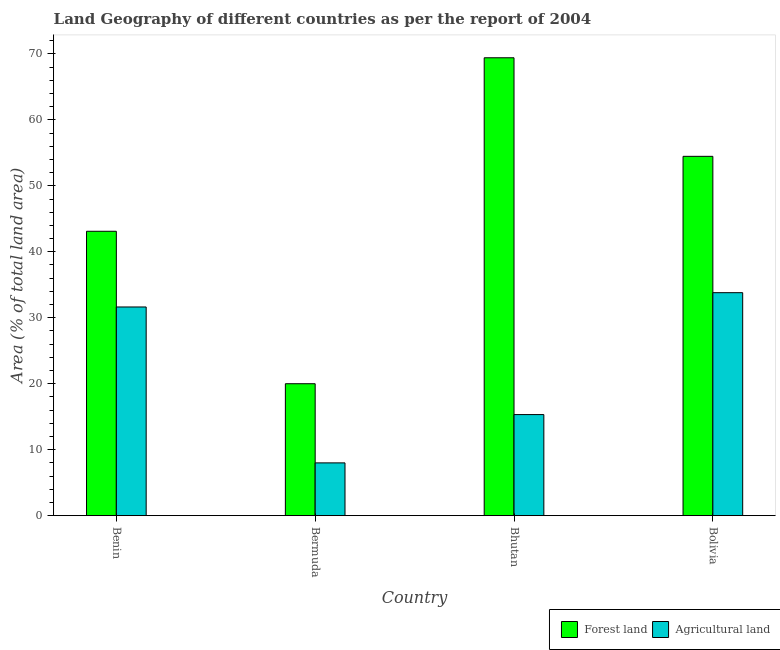How many different coloured bars are there?
Your answer should be very brief. 2. Are the number of bars per tick equal to the number of legend labels?
Keep it short and to the point. Yes. How many bars are there on the 2nd tick from the left?
Keep it short and to the point. 2. What is the label of the 1st group of bars from the left?
Keep it short and to the point. Benin. In how many cases, is the number of bars for a given country not equal to the number of legend labels?
Give a very brief answer. 0. What is the percentage of land area under forests in Bolivia?
Give a very brief answer. 54.47. Across all countries, what is the maximum percentage of land area under forests?
Your answer should be compact. 69.41. Across all countries, what is the minimum percentage of land area under agriculture?
Give a very brief answer. 8. In which country was the percentage of land area under agriculture minimum?
Provide a short and direct response. Bermuda. What is the total percentage of land area under forests in the graph?
Make the answer very short. 186.99. What is the difference between the percentage of land area under forests in Bermuda and that in Bhutan?
Provide a succinct answer. -49.41. What is the difference between the percentage of land area under agriculture in Bolivia and the percentage of land area under forests in Benin?
Provide a succinct answer. -9.31. What is the average percentage of land area under agriculture per country?
Make the answer very short. 22.19. What is the difference between the percentage of land area under agriculture and percentage of land area under forests in Benin?
Keep it short and to the point. -11.48. In how many countries, is the percentage of land area under forests greater than 2 %?
Keep it short and to the point. 4. What is the ratio of the percentage of land area under forests in Bhutan to that in Bolivia?
Make the answer very short. 1.27. Is the percentage of land area under forests in Benin less than that in Bolivia?
Make the answer very short. Yes. What is the difference between the highest and the second highest percentage of land area under agriculture?
Your answer should be compact. 2.17. What is the difference between the highest and the lowest percentage of land area under forests?
Offer a terse response. 49.41. In how many countries, is the percentage of land area under forests greater than the average percentage of land area under forests taken over all countries?
Keep it short and to the point. 2. What does the 2nd bar from the left in Bhutan represents?
Provide a short and direct response. Agricultural land. What does the 2nd bar from the right in Bolivia represents?
Your answer should be very brief. Forest land. How many bars are there?
Your answer should be compact. 8. Are all the bars in the graph horizontal?
Offer a very short reply. No. How many countries are there in the graph?
Keep it short and to the point. 4. What is the difference between two consecutive major ticks on the Y-axis?
Offer a very short reply. 10. Does the graph contain grids?
Your answer should be very brief. No. What is the title of the graph?
Provide a succinct answer. Land Geography of different countries as per the report of 2004. Does "ODA received" appear as one of the legend labels in the graph?
Offer a terse response. No. What is the label or title of the Y-axis?
Offer a very short reply. Area (% of total land area). What is the Area (% of total land area) in Forest land in Benin?
Provide a succinct answer. 43.11. What is the Area (% of total land area) of Agricultural land in Benin?
Provide a succinct answer. 31.63. What is the Area (% of total land area) of Forest land in Bermuda?
Offer a terse response. 20. What is the Area (% of total land area) of Agricultural land in Bermuda?
Provide a short and direct response. 8. What is the Area (% of total land area) in Forest land in Bhutan?
Provide a succinct answer. 69.41. What is the Area (% of total land area) in Agricultural land in Bhutan?
Provide a short and direct response. 15.32. What is the Area (% of total land area) of Forest land in Bolivia?
Provide a short and direct response. 54.47. What is the Area (% of total land area) of Agricultural land in Bolivia?
Provide a succinct answer. 33.8. Across all countries, what is the maximum Area (% of total land area) in Forest land?
Provide a succinct answer. 69.41. Across all countries, what is the maximum Area (% of total land area) in Agricultural land?
Keep it short and to the point. 33.8. What is the total Area (% of total land area) in Forest land in the graph?
Ensure brevity in your answer.  186.99. What is the total Area (% of total land area) in Agricultural land in the graph?
Provide a succinct answer. 88.76. What is the difference between the Area (% of total land area) of Forest land in Benin and that in Bermuda?
Ensure brevity in your answer.  23.11. What is the difference between the Area (% of total land area) in Agricultural land in Benin and that in Bermuda?
Provide a succinct answer. 23.63. What is the difference between the Area (% of total land area) of Forest land in Benin and that in Bhutan?
Make the answer very short. -26.3. What is the difference between the Area (% of total land area) of Agricultural land in Benin and that in Bhutan?
Offer a terse response. 16.31. What is the difference between the Area (% of total land area) in Forest land in Benin and that in Bolivia?
Give a very brief answer. -11.36. What is the difference between the Area (% of total land area) in Agricultural land in Benin and that in Bolivia?
Offer a very short reply. -2.17. What is the difference between the Area (% of total land area) in Forest land in Bermuda and that in Bhutan?
Give a very brief answer. -49.41. What is the difference between the Area (% of total land area) in Agricultural land in Bermuda and that in Bhutan?
Your answer should be very brief. -7.32. What is the difference between the Area (% of total land area) of Forest land in Bermuda and that in Bolivia?
Ensure brevity in your answer.  -34.47. What is the difference between the Area (% of total land area) in Agricultural land in Bermuda and that in Bolivia?
Provide a succinct answer. -25.8. What is the difference between the Area (% of total land area) in Forest land in Bhutan and that in Bolivia?
Keep it short and to the point. 14.94. What is the difference between the Area (% of total land area) of Agricultural land in Bhutan and that in Bolivia?
Keep it short and to the point. -18.48. What is the difference between the Area (% of total land area) in Forest land in Benin and the Area (% of total land area) in Agricultural land in Bermuda?
Your response must be concise. 35.11. What is the difference between the Area (% of total land area) in Forest land in Benin and the Area (% of total land area) in Agricultural land in Bhutan?
Provide a succinct answer. 27.79. What is the difference between the Area (% of total land area) in Forest land in Benin and the Area (% of total land area) in Agricultural land in Bolivia?
Keep it short and to the point. 9.31. What is the difference between the Area (% of total land area) of Forest land in Bermuda and the Area (% of total land area) of Agricultural land in Bhutan?
Keep it short and to the point. 4.68. What is the difference between the Area (% of total land area) in Forest land in Bermuda and the Area (% of total land area) in Agricultural land in Bolivia?
Keep it short and to the point. -13.8. What is the difference between the Area (% of total land area) in Forest land in Bhutan and the Area (% of total land area) in Agricultural land in Bolivia?
Offer a very short reply. 35.61. What is the average Area (% of total land area) in Forest land per country?
Keep it short and to the point. 46.75. What is the average Area (% of total land area) of Agricultural land per country?
Ensure brevity in your answer.  22.19. What is the difference between the Area (% of total land area) of Forest land and Area (% of total land area) of Agricultural land in Benin?
Provide a short and direct response. 11.48. What is the difference between the Area (% of total land area) in Forest land and Area (% of total land area) in Agricultural land in Bermuda?
Ensure brevity in your answer.  12. What is the difference between the Area (% of total land area) of Forest land and Area (% of total land area) of Agricultural land in Bhutan?
Your answer should be very brief. 54.09. What is the difference between the Area (% of total land area) in Forest land and Area (% of total land area) in Agricultural land in Bolivia?
Give a very brief answer. 20.67. What is the ratio of the Area (% of total land area) in Forest land in Benin to that in Bermuda?
Make the answer very short. 2.16. What is the ratio of the Area (% of total land area) in Agricultural land in Benin to that in Bermuda?
Your answer should be compact. 3.95. What is the ratio of the Area (% of total land area) of Forest land in Benin to that in Bhutan?
Your response must be concise. 0.62. What is the ratio of the Area (% of total land area) in Agricultural land in Benin to that in Bhutan?
Make the answer very short. 2.06. What is the ratio of the Area (% of total land area) of Forest land in Benin to that in Bolivia?
Give a very brief answer. 0.79. What is the ratio of the Area (% of total land area) of Agricultural land in Benin to that in Bolivia?
Keep it short and to the point. 0.94. What is the ratio of the Area (% of total land area) in Forest land in Bermuda to that in Bhutan?
Give a very brief answer. 0.29. What is the ratio of the Area (% of total land area) in Agricultural land in Bermuda to that in Bhutan?
Ensure brevity in your answer.  0.52. What is the ratio of the Area (% of total land area) in Forest land in Bermuda to that in Bolivia?
Ensure brevity in your answer.  0.37. What is the ratio of the Area (% of total land area) in Agricultural land in Bermuda to that in Bolivia?
Ensure brevity in your answer.  0.24. What is the ratio of the Area (% of total land area) of Forest land in Bhutan to that in Bolivia?
Make the answer very short. 1.27. What is the ratio of the Area (% of total land area) in Agricultural land in Bhutan to that in Bolivia?
Ensure brevity in your answer.  0.45. What is the difference between the highest and the second highest Area (% of total land area) in Forest land?
Offer a very short reply. 14.94. What is the difference between the highest and the second highest Area (% of total land area) of Agricultural land?
Provide a short and direct response. 2.17. What is the difference between the highest and the lowest Area (% of total land area) in Forest land?
Give a very brief answer. 49.41. What is the difference between the highest and the lowest Area (% of total land area) of Agricultural land?
Your response must be concise. 25.8. 